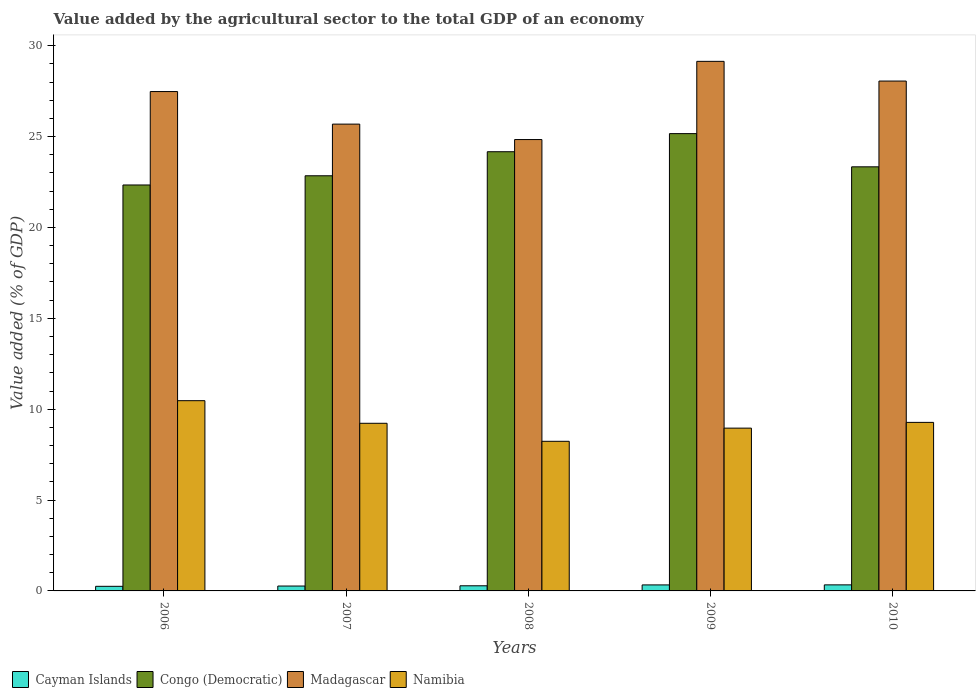How many different coloured bars are there?
Give a very brief answer. 4. Are the number of bars on each tick of the X-axis equal?
Offer a very short reply. Yes. In how many cases, is the number of bars for a given year not equal to the number of legend labels?
Offer a terse response. 0. What is the value added by the agricultural sector to the total GDP in Congo (Democratic) in 2009?
Provide a succinct answer. 25.16. Across all years, what is the maximum value added by the agricultural sector to the total GDP in Madagascar?
Make the answer very short. 29.14. Across all years, what is the minimum value added by the agricultural sector to the total GDP in Namibia?
Provide a succinct answer. 8.23. What is the total value added by the agricultural sector to the total GDP in Namibia in the graph?
Give a very brief answer. 46.16. What is the difference between the value added by the agricultural sector to the total GDP in Cayman Islands in 2007 and that in 2010?
Ensure brevity in your answer.  -0.06. What is the difference between the value added by the agricultural sector to the total GDP in Madagascar in 2007 and the value added by the agricultural sector to the total GDP in Cayman Islands in 2006?
Ensure brevity in your answer.  25.44. What is the average value added by the agricultural sector to the total GDP in Madagascar per year?
Give a very brief answer. 27.04. In the year 2010, what is the difference between the value added by the agricultural sector to the total GDP in Namibia and value added by the agricultural sector to the total GDP in Madagascar?
Offer a very short reply. -18.78. What is the ratio of the value added by the agricultural sector to the total GDP in Namibia in 2009 to that in 2010?
Keep it short and to the point. 0.97. Is the difference between the value added by the agricultural sector to the total GDP in Namibia in 2006 and 2010 greater than the difference between the value added by the agricultural sector to the total GDP in Madagascar in 2006 and 2010?
Your response must be concise. Yes. What is the difference between the highest and the second highest value added by the agricultural sector to the total GDP in Cayman Islands?
Ensure brevity in your answer.  0. What is the difference between the highest and the lowest value added by the agricultural sector to the total GDP in Congo (Democratic)?
Provide a short and direct response. 2.83. Is the sum of the value added by the agricultural sector to the total GDP in Cayman Islands in 2007 and 2010 greater than the maximum value added by the agricultural sector to the total GDP in Congo (Democratic) across all years?
Ensure brevity in your answer.  No. Is it the case that in every year, the sum of the value added by the agricultural sector to the total GDP in Congo (Democratic) and value added by the agricultural sector to the total GDP in Cayman Islands is greater than the sum of value added by the agricultural sector to the total GDP in Namibia and value added by the agricultural sector to the total GDP in Madagascar?
Provide a short and direct response. No. What does the 3rd bar from the left in 2009 represents?
Make the answer very short. Madagascar. What does the 4th bar from the right in 2008 represents?
Keep it short and to the point. Cayman Islands. Is it the case that in every year, the sum of the value added by the agricultural sector to the total GDP in Namibia and value added by the agricultural sector to the total GDP in Congo (Democratic) is greater than the value added by the agricultural sector to the total GDP in Madagascar?
Make the answer very short. Yes. How many bars are there?
Your answer should be very brief. 20. What is the difference between two consecutive major ticks on the Y-axis?
Your answer should be compact. 5. Does the graph contain any zero values?
Ensure brevity in your answer.  No. How are the legend labels stacked?
Keep it short and to the point. Horizontal. What is the title of the graph?
Offer a terse response. Value added by the agricultural sector to the total GDP of an economy. What is the label or title of the Y-axis?
Offer a very short reply. Value added (% of GDP). What is the Value added (% of GDP) of Cayman Islands in 2006?
Your answer should be compact. 0.25. What is the Value added (% of GDP) in Congo (Democratic) in 2006?
Offer a very short reply. 22.34. What is the Value added (% of GDP) of Madagascar in 2006?
Offer a very short reply. 27.48. What is the Value added (% of GDP) of Namibia in 2006?
Provide a succinct answer. 10.47. What is the Value added (% of GDP) in Cayman Islands in 2007?
Keep it short and to the point. 0.27. What is the Value added (% of GDP) in Congo (Democratic) in 2007?
Your response must be concise. 22.85. What is the Value added (% of GDP) in Madagascar in 2007?
Provide a succinct answer. 25.69. What is the Value added (% of GDP) of Namibia in 2007?
Make the answer very short. 9.22. What is the Value added (% of GDP) in Cayman Islands in 2008?
Keep it short and to the point. 0.28. What is the Value added (% of GDP) of Congo (Democratic) in 2008?
Offer a very short reply. 24.17. What is the Value added (% of GDP) of Madagascar in 2008?
Your response must be concise. 24.84. What is the Value added (% of GDP) in Namibia in 2008?
Offer a very short reply. 8.23. What is the Value added (% of GDP) in Cayman Islands in 2009?
Ensure brevity in your answer.  0.33. What is the Value added (% of GDP) in Congo (Democratic) in 2009?
Offer a terse response. 25.16. What is the Value added (% of GDP) of Madagascar in 2009?
Provide a short and direct response. 29.14. What is the Value added (% of GDP) of Namibia in 2009?
Your response must be concise. 8.96. What is the Value added (% of GDP) of Cayman Islands in 2010?
Your answer should be compact. 0.33. What is the Value added (% of GDP) in Congo (Democratic) in 2010?
Your answer should be compact. 23.34. What is the Value added (% of GDP) of Madagascar in 2010?
Provide a short and direct response. 28.06. What is the Value added (% of GDP) in Namibia in 2010?
Offer a very short reply. 9.27. Across all years, what is the maximum Value added (% of GDP) of Cayman Islands?
Provide a succinct answer. 0.33. Across all years, what is the maximum Value added (% of GDP) in Congo (Democratic)?
Offer a very short reply. 25.16. Across all years, what is the maximum Value added (% of GDP) in Madagascar?
Ensure brevity in your answer.  29.14. Across all years, what is the maximum Value added (% of GDP) of Namibia?
Your answer should be very brief. 10.47. Across all years, what is the minimum Value added (% of GDP) of Cayman Islands?
Your answer should be very brief. 0.25. Across all years, what is the minimum Value added (% of GDP) of Congo (Democratic)?
Your answer should be very brief. 22.34. Across all years, what is the minimum Value added (% of GDP) in Madagascar?
Your answer should be very brief. 24.84. Across all years, what is the minimum Value added (% of GDP) in Namibia?
Ensure brevity in your answer.  8.23. What is the total Value added (% of GDP) in Cayman Islands in the graph?
Offer a terse response. 1.47. What is the total Value added (% of GDP) of Congo (Democratic) in the graph?
Provide a short and direct response. 117.85. What is the total Value added (% of GDP) of Madagascar in the graph?
Your response must be concise. 135.21. What is the total Value added (% of GDP) in Namibia in the graph?
Make the answer very short. 46.16. What is the difference between the Value added (% of GDP) of Cayman Islands in 2006 and that in 2007?
Keep it short and to the point. -0.02. What is the difference between the Value added (% of GDP) in Congo (Democratic) in 2006 and that in 2007?
Your answer should be very brief. -0.51. What is the difference between the Value added (% of GDP) of Madagascar in 2006 and that in 2007?
Provide a short and direct response. 1.79. What is the difference between the Value added (% of GDP) of Namibia in 2006 and that in 2007?
Offer a very short reply. 1.24. What is the difference between the Value added (% of GDP) in Cayman Islands in 2006 and that in 2008?
Your answer should be compact. -0.03. What is the difference between the Value added (% of GDP) of Congo (Democratic) in 2006 and that in 2008?
Offer a very short reply. -1.83. What is the difference between the Value added (% of GDP) in Madagascar in 2006 and that in 2008?
Offer a very short reply. 2.64. What is the difference between the Value added (% of GDP) of Namibia in 2006 and that in 2008?
Your answer should be very brief. 2.24. What is the difference between the Value added (% of GDP) in Cayman Islands in 2006 and that in 2009?
Provide a short and direct response. -0.08. What is the difference between the Value added (% of GDP) in Congo (Democratic) in 2006 and that in 2009?
Ensure brevity in your answer.  -2.83. What is the difference between the Value added (% of GDP) of Madagascar in 2006 and that in 2009?
Ensure brevity in your answer.  -1.66. What is the difference between the Value added (% of GDP) of Namibia in 2006 and that in 2009?
Ensure brevity in your answer.  1.51. What is the difference between the Value added (% of GDP) in Cayman Islands in 2006 and that in 2010?
Ensure brevity in your answer.  -0.08. What is the difference between the Value added (% of GDP) of Congo (Democratic) in 2006 and that in 2010?
Offer a terse response. -1. What is the difference between the Value added (% of GDP) of Madagascar in 2006 and that in 2010?
Provide a short and direct response. -0.58. What is the difference between the Value added (% of GDP) in Namibia in 2006 and that in 2010?
Your answer should be very brief. 1.19. What is the difference between the Value added (% of GDP) of Cayman Islands in 2007 and that in 2008?
Your response must be concise. -0.01. What is the difference between the Value added (% of GDP) in Congo (Democratic) in 2007 and that in 2008?
Your answer should be compact. -1.32. What is the difference between the Value added (% of GDP) of Madagascar in 2007 and that in 2008?
Make the answer very short. 0.85. What is the difference between the Value added (% of GDP) in Cayman Islands in 2007 and that in 2009?
Make the answer very short. -0.06. What is the difference between the Value added (% of GDP) of Congo (Democratic) in 2007 and that in 2009?
Your response must be concise. -2.32. What is the difference between the Value added (% of GDP) of Madagascar in 2007 and that in 2009?
Your answer should be compact. -3.45. What is the difference between the Value added (% of GDP) of Namibia in 2007 and that in 2009?
Keep it short and to the point. 0.27. What is the difference between the Value added (% of GDP) in Cayman Islands in 2007 and that in 2010?
Offer a terse response. -0.06. What is the difference between the Value added (% of GDP) of Congo (Democratic) in 2007 and that in 2010?
Offer a very short reply. -0.49. What is the difference between the Value added (% of GDP) of Madagascar in 2007 and that in 2010?
Offer a very short reply. -2.37. What is the difference between the Value added (% of GDP) in Namibia in 2007 and that in 2010?
Provide a succinct answer. -0.05. What is the difference between the Value added (% of GDP) in Cayman Islands in 2008 and that in 2009?
Offer a terse response. -0.05. What is the difference between the Value added (% of GDP) in Congo (Democratic) in 2008 and that in 2009?
Offer a terse response. -1. What is the difference between the Value added (% of GDP) in Madagascar in 2008 and that in 2009?
Give a very brief answer. -4.3. What is the difference between the Value added (% of GDP) in Namibia in 2008 and that in 2009?
Offer a very short reply. -0.72. What is the difference between the Value added (% of GDP) of Cayman Islands in 2008 and that in 2010?
Provide a succinct answer. -0.05. What is the difference between the Value added (% of GDP) of Congo (Democratic) in 2008 and that in 2010?
Ensure brevity in your answer.  0.83. What is the difference between the Value added (% of GDP) of Madagascar in 2008 and that in 2010?
Offer a terse response. -3.22. What is the difference between the Value added (% of GDP) in Namibia in 2008 and that in 2010?
Your answer should be compact. -1.04. What is the difference between the Value added (% of GDP) of Cayman Islands in 2009 and that in 2010?
Make the answer very short. -0. What is the difference between the Value added (% of GDP) in Congo (Democratic) in 2009 and that in 2010?
Your answer should be compact. 1.83. What is the difference between the Value added (% of GDP) of Madagascar in 2009 and that in 2010?
Offer a terse response. 1.08. What is the difference between the Value added (% of GDP) of Namibia in 2009 and that in 2010?
Ensure brevity in your answer.  -0.32. What is the difference between the Value added (% of GDP) of Cayman Islands in 2006 and the Value added (% of GDP) of Congo (Democratic) in 2007?
Your response must be concise. -22.59. What is the difference between the Value added (% of GDP) in Cayman Islands in 2006 and the Value added (% of GDP) in Madagascar in 2007?
Your answer should be very brief. -25.44. What is the difference between the Value added (% of GDP) in Cayman Islands in 2006 and the Value added (% of GDP) in Namibia in 2007?
Make the answer very short. -8.97. What is the difference between the Value added (% of GDP) of Congo (Democratic) in 2006 and the Value added (% of GDP) of Madagascar in 2007?
Give a very brief answer. -3.35. What is the difference between the Value added (% of GDP) of Congo (Democratic) in 2006 and the Value added (% of GDP) of Namibia in 2007?
Ensure brevity in your answer.  13.11. What is the difference between the Value added (% of GDP) of Madagascar in 2006 and the Value added (% of GDP) of Namibia in 2007?
Provide a short and direct response. 18.26. What is the difference between the Value added (% of GDP) in Cayman Islands in 2006 and the Value added (% of GDP) in Congo (Democratic) in 2008?
Provide a succinct answer. -23.92. What is the difference between the Value added (% of GDP) of Cayman Islands in 2006 and the Value added (% of GDP) of Madagascar in 2008?
Ensure brevity in your answer.  -24.59. What is the difference between the Value added (% of GDP) of Cayman Islands in 2006 and the Value added (% of GDP) of Namibia in 2008?
Your response must be concise. -7.98. What is the difference between the Value added (% of GDP) in Congo (Democratic) in 2006 and the Value added (% of GDP) in Madagascar in 2008?
Keep it short and to the point. -2.5. What is the difference between the Value added (% of GDP) in Congo (Democratic) in 2006 and the Value added (% of GDP) in Namibia in 2008?
Give a very brief answer. 14.11. What is the difference between the Value added (% of GDP) of Madagascar in 2006 and the Value added (% of GDP) of Namibia in 2008?
Your answer should be compact. 19.25. What is the difference between the Value added (% of GDP) in Cayman Islands in 2006 and the Value added (% of GDP) in Congo (Democratic) in 2009?
Your response must be concise. -24.91. What is the difference between the Value added (% of GDP) of Cayman Islands in 2006 and the Value added (% of GDP) of Madagascar in 2009?
Make the answer very short. -28.89. What is the difference between the Value added (% of GDP) of Cayman Islands in 2006 and the Value added (% of GDP) of Namibia in 2009?
Provide a succinct answer. -8.71. What is the difference between the Value added (% of GDP) of Congo (Democratic) in 2006 and the Value added (% of GDP) of Madagascar in 2009?
Keep it short and to the point. -6.8. What is the difference between the Value added (% of GDP) in Congo (Democratic) in 2006 and the Value added (% of GDP) in Namibia in 2009?
Give a very brief answer. 13.38. What is the difference between the Value added (% of GDP) of Madagascar in 2006 and the Value added (% of GDP) of Namibia in 2009?
Provide a succinct answer. 18.52. What is the difference between the Value added (% of GDP) in Cayman Islands in 2006 and the Value added (% of GDP) in Congo (Democratic) in 2010?
Offer a very short reply. -23.08. What is the difference between the Value added (% of GDP) of Cayman Islands in 2006 and the Value added (% of GDP) of Madagascar in 2010?
Offer a terse response. -27.8. What is the difference between the Value added (% of GDP) of Cayman Islands in 2006 and the Value added (% of GDP) of Namibia in 2010?
Ensure brevity in your answer.  -9.02. What is the difference between the Value added (% of GDP) in Congo (Democratic) in 2006 and the Value added (% of GDP) in Madagascar in 2010?
Offer a very short reply. -5.72. What is the difference between the Value added (% of GDP) in Congo (Democratic) in 2006 and the Value added (% of GDP) in Namibia in 2010?
Ensure brevity in your answer.  13.06. What is the difference between the Value added (% of GDP) in Madagascar in 2006 and the Value added (% of GDP) in Namibia in 2010?
Give a very brief answer. 18.21. What is the difference between the Value added (% of GDP) of Cayman Islands in 2007 and the Value added (% of GDP) of Congo (Democratic) in 2008?
Your answer should be very brief. -23.9. What is the difference between the Value added (% of GDP) in Cayman Islands in 2007 and the Value added (% of GDP) in Madagascar in 2008?
Offer a very short reply. -24.57. What is the difference between the Value added (% of GDP) in Cayman Islands in 2007 and the Value added (% of GDP) in Namibia in 2008?
Your answer should be very brief. -7.96. What is the difference between the Value added (% of GDP) of Congo (Democratic) in 2007 and the Value added (% of GDP) of Madagascar in 2008?
Your response must be concise. -1.99. What is the difference between the Value added (% of GDP) in Congo (Democratic) in 2007 and the Value added (% of GDP) in Namibia in 2008?
Make the answer very short. 14.61. What is the difference between the Value added (% of GDP) of Madagascar in 2007 and the Value added (% of GDP) of Namibia in 2008?
Provide a short and direct response. 17.45. What is the difference between the Value added (% of GDP) of Cayman Islands in 2007 and the Value added (% of GDP) of Congo (Democratic) in 2009?
Provide a short and direct response. -24.9. What is the difference between the Value added (% of GDP) of Cayman Islands in 2007 and the Value added (% of GDP) of Madagascar in 2009?
Offer a very short reply. -28.87. What is the difference between the Value added (% of GDP) of Cayman Islands in 2007 and the Value added (% of GDP) of Namibia in 2009?
Ensure brevity in your answer.  -8.69. What is the difference between the Value added (% of GDP) in Congo (Democratic) in 2007 and the Value added (% of GDP) in Madagascar in 2009?
Offer a very short reply. -6.3. What is the difference between the Value added (% of GDP) in Congo (Democratic) in 2007 and the Value added (% of GDP) in Namibia in 2009?
Provide a succinct answer. 13.89. What is the difference between the Value added (% of GDP) in Madagascar in 2007 and the Value added (% of GDP) in Namibia in 2009?
Keep it short and to the point. 16.73. What is the difference between the Value added (% of GDP) of Cayman Islands in 2007 and the Value added (% of GDP) of Congo (Democratic) in 2010?
Your response must be concise. -23.07. What is the difference between the Value added (% of GDP) of Cayman Islands in 2007 and the Value added (% of GDP) of Madagascar in 2010?
Provide a succinct answer. -27.79. What is the difference between the Value added (% of GDP) of Cayman Islands in 2007 and the Value added (% of GDP) of Namibia in 2010?
Give a very brief answer. -9.01. What is the difference between the Value added (% of GDP) of Congo (Democratic) in 2007 and the Value added (% of GDP) of Madagascar in 2010?
Ensure brevity in your answer.  -5.21. What is the difference between the Value added (% of GDP) in Congo (Democratic) in 2007 and the Value added (% of GDP) in Namibia in 2010?
Provide a succinct answer. 13.57. What is the difference between the Value added (% of GDP) in Madagascar in 2007 and the Value added (% of GDP) in Namibia in 2010?
Provide a succinct answer. 16.41. What is the difference between the Value added (% of GDP) in Cayman Islands in 2008 and the Value added (% of GDP) in Congo (Democratic) in 2009?
Give a very brief answer. -24.88. What is the difference between the Value added (% of GDP) in Cayman Islands in 2008 and the Value added (% of GDP) in Madagascar in 2009?
Provide a succinct answer. -28.86. What is the difference between the Value added (% of GDP) in Cayman Islands in 2008 and the Value added (% of GDP) in Namibia in 2009?
Provide a short and direct response. -8.68. What is the difference between the Value added (% of GDP) of Congo (Democratic) in 2008 and the Value added (% of GDP) of Madagascar in 2009?
Give a very brief answer. -4.97. What is the difference between the Value added (% of GDP) of Congo (Democratic) in 2008 and the Value added (% of GDP) of Namibia in 2009?
Ensure brevity in your answer.  15.21. What is the difference between the Value added (% of GDP) in Madagascar in 2008 and the Value added (% of GDP) in Namibia in 2009?
Offer a very short reply. 15.88. What is the difference between the Value added (% of GDP) in Cayman Islands in 2008 and the Value added (% of GDP) in Congo (Democratic) in 2010?
Your answer should be compact. -23.06. What is the difference between the Value added (% of GDP) in Cayman Islands in 2008 and the Value added (% of GDP) in Madagascar in 2010?
Give a very brief answer. -27.78. What is the difference between the Value added (% of GDP) in Cayman Islands in 2008 and the Value added (% of GDP) in Namibia in 2010?
Provide a short and direct response. -8.99. What is the difference between the Value added (% of GDP) of Congo (Democratic) in 2008 and the Value added (% of GDP) of Madagascar in 2010?
Offer a terse response. -3.89. What is the difference between the Value added (% of GDP) in Congo (Democratic) in 2008 and the Value added (% of GDP) in Namibia in 2010?
Keep it short and to the point. 14.89. What is the difference between the Value added (% of GDP) in Madagascar in 2008 and the Value added (% of GDP) in Namibia in 2010?
Ensure brevity in your answer.  15.56. What is the difference between the Value added (% of GDP) in Cayman Islands in 2009 and the Value added (% of GDP) in Congo (Democratic) in 2010?
Offer a very short reply. -23.01. What is the difference between the Value added (% of GDP) in Cayman Islands in 2009 and the Value added (% of GDP) in Madagascar in 2010?
Offer a terse response. -27.73. What is the difference between the Value added (% of GDP) in Cayman Islands in 2009 and the Value added (% of GDP) in Namibia in 2010?
Ensure brevity in your answer.  -8.94. What is the difference between the Value added (% of GDP) of Congo (Democratic) in 2009 and the Value added (% of GDP) of Madagascar in 2010?
Offer a terse response. -2.89. What is the difference between the Value added (% of GDP) of Congo (Democratic) in 2009 and the Value added (% of GDP) of Namibia in 2010?
Ensure brevity in your answer.  15.89. What is the difference between the Value added (% of GDP) of Madagascar in 2009 and the Value added (% of GDP) of Namibia in 2010?
Your answer should be very brief. 19.87. What is the average Value added (% of GDP) in Cayman Islands per year?
Offer a very short reply. 0.29. What is the average Value added (% of GDP) of Congo (Democratic) per year?
Provide a succinct answer. 23.57. What is the average Value added (% of GDP) in Madagascar per year?
Offer a terse response. 27.04. What is the average Value added (% of GDP) of Namibia per year?
Keep it short and to the point. 9.23. In the year 2006, what is the difference between the Value added (% of GDP) in Cayman Islands and Value added (% of GDP) in Congo (Democratic)?
Ensure brevity in your answer.  -22.09. In the year 2006, what is the difference between the Value added (% of GDP) in Cayman Islands and Value added (% of GDP) in Madagascar?
Give a very brief answer. -27.23. In the year 2006, what is the difference between the Value added (% of GDP) of Cayman Islands and Value added (% of GDP) of Namibia?
Provide a short and direct response. -10.22. In the year 2006, what is the difference between the Value added (% of GDP) of Congo (Democratic) and Value added (% of GDP) of Madagascar?
Offer a very short reply. -5.14. In the year 2006, what is the difference between the Value added (% of GDP) in Congo (Democratic) and Value added (% of GDP) in Namibia?
Give a very brief answer. 11.87. In the year 2006, what is the difference between the Value added (% of GDP) in Madagascar and Value added (% of GDP) in Namibia?
Offer a very short reply. 17.01. In the year 2007, what is the difference between the Value added (% of GDP) in Cayman Islands and Value added (% of GDP) in Congo (Democratic)?
Your response must be concise. -22.58. In the year 2007, what is the difference between the Value added (% of GDP) in Cayman Islands and Value added (% of GDP) in Madagascar?
Ensure brevity in your answer.  -25.42. In the year 2007, what is the difference between the Value added (% of GDP) in Cayman Islands and Value added (% of GDP) in Namibia?
Keep it short and to the point. -8.96. In the year 2007, what is the difference between the Value added (% of GDP) in Congo (Democratic) and Value added (% of GDP) in Madagascar?
Make the answer very short. -2.84. In the year 2007, what is the difference between the Value added (% of GDP) of Congo (Democratic) and Value added (% of GDP) of Namibia?
Keep it short and to the point. 13.62. In the year 2007, what is the difference between the Value added (% of GDP) of Madagascar and Value added (% of GDP) of Namibia?
Your answer should be compact. 16.46. In the year 2008, what is the difference between the Value added (% of GDP) in Cayman Islands and Value added (% of GDP) in Congo (Democratic)?
Your response must be concise. -23.89. In the year 2008, what is the difference between the Value added (% of GDP) in Cayman Islands and Value added (% of GDP) in Madagascar?
Your response must be concise. -24.56. In the year 2008, what is the difference between the Value added (% of GDP) of Cayman Islands and Value added (% of GDP) of Namibia?
Provide a succinct answer. -7.95. In the year 2008, what is the difference between the Value added (% of GDP) in Congo (Democratic) and Value added (% of GDP) in Madagascar?
Your answer should be compact. -0.67. In the year 2008, what is the difference between the Value added (% of GDP) of Congo (Democratic) and Value added (% of GDP) of Namibia?
Ensure brevity in your answer.  15.94. In the year 2008, what is the difference between the Value added (% of GDP) of Madagascar and Value added (% of GDP) of Namibia?
Offer a terse response. 16.61. In the year 2009, what is the difference between the Value added (% of GDP) in Cayman Islands and Value added (% of GDP) in Congo (Democratic)?
Offer a very short reply. -24.83. In the year 2009, what is the difference between the Value added (% of GDP) of Cayman Islands and Value added (% of GDP) of Madagascar?
Offer a terse response. -28.81. In the year 2009, what is the difference between the Value added (% of GDP) in Cayman Islands and Value added (% of GDP) in Namibia?
Ensure brevity in your answer.  -8.63. In the year 2009, what is the difference between the Value added (% of GDP) of Congo (Democratic) and Value added (% of GDP) of Madagascar?
Offer a terse response. -3.98. In the year 2009, what is the difference between the Value added (% of GDP) in Congo (Democratic) and Value added (% of GDP) in Namibia?
Ensure brevity in your answer.  16.21. In the year 2009, what is the difference between the Value added (% of GDP) in Madagascar and Value added (% of GDP) in Namibia?
Keep it short and to the point. 20.18. In the year 2010, what is the difference between the Value added (% of GDP) in Cayman Islands and Value added (% of GDP) in Congo (Democratic)?
Your answer should be compact. -23. In the year 2010, what is the difference between the Value added (% of GDP) in Cayman Islands and Value added (% of GDP) in Madagascar?
Offer a terse response. -27.72. In the year 2010, what is the difference between the Value added (% of GDP) of Cayman Islands and Value added (% of GDP) of Namibia?
Offer a very short reply. -8.94. In the year 2010, what is the difference between the Value added (% of GDP) in Congo (Democratic) and Value added (% of GDP) in Madagascar?
Make the answer very short. -4.72. In the year 2010, what is the difference between the Value added (% of GDP) of Congo (Democratic) and Value added (% of GDP) of Namibia?
Keep it short and to the point. 14.06. In the year 2010, what is the difference between the Value added (% of GDP) in Madagascar and Value added (% of GDP) in Namibia?
Ensure brevity in your answer.  18.78. What is the ratio of the Value added (% of GDP) of Cayman Islands in 2006 to that in 2007?
Make the answer very short. 0.94. What is the ratio of the Value added (% of GDP) of Congo (Democratic) in 2006 to that in 2007?
Ensure brevity in your answer.  0.98. What is the ratio of the Value added (% of GDP) in Madagascar in 2006 to that in 2007?
Your response must be concise. 1.07. What is the ratio of the Value added (% of GDP) of Namibia in 2006 to that in 2007?
Your answer should be compact. 1.13. What is the ratio of the Value added (% of GDP) of Cayman Islands in 2006 to that in 2008?
Ensure brevity in your answer.  0.9. What is the ratio of the Value added (% of GDP) in Congo (Democratic) in 2006 to that in 2008?
Offer a very short reply. 0.92. What is the ratio of the Value added (% of GDP) of Madagascar in 2006 to that in 2008?
Provide a short and direct response. 1.11. What is the ratio of the Value added (% of GDP) of Namibia in 2006 to that in 2008?
Your answer should be compact. 1.27. What is the ratio of the Value added (% of GDP) of Cayman Islands in 2006 to that in 2009?
Keep it short and to the point. 0.76. What is the ratio of the Value added (% of GDP) in Congo (Democratic) in 2006 to that in 2009?
Ensure brevity in your answer.  0.89. What is the ratio of the Value added (% of GDP) of Madagascar in 2006 to that in 2009?
Your response must be concise. 0.94. What is the ratio of the Value added (% of GDP) of Namibia in 2006 to that in 2009?
Keep it short and to the point. 1.17. What is the ratio of the Value added (% of GDP) of Cayman Islands in 2006 to that in 2010?
Your answer should be compact. 0.76. What is the ratio of the Value added (% of GDP) in Congo (Democratic) in 2006 to that in 2010?
Keep it short and to the point. 0.96. What is the ratio of the Value added (% of GDP) of Madagascar in 2006 to that in 2010?
Your answer should be very brief. 0.98. What is the ratio of the Value added (% of GDP) in Namibia in 2006 to that in 2010?
Offer a very short reply. 1.13. What is the ratio of the Value added (% of GDP) in Cayman Islands in 2007 to that in 2008?
Your response must be concise. 0.95. What is the ratio of the Value added (% of GDP) in Congo (Democratic) in 2007 to that in 2008?
Provide a succinct answer. 0.95. What is the ratio of the Value added (% of GDP) in Madagascar in 2007 to that in 2008?
Ensure brevity in your answer.  1.03. What is the ratio of the Value added (% of GDP) in Namibia in 2007 to that in 2008?
Ensure brevity in your answer.  1.12. What is the ratio of the Value added (% of GDP) of Cayman Islands in 2007 to that in 2009?
Offer a terse response. 0.81. What is the ratio of the Value added (% of GDP) of Congo (Democratic) in 2007 to that in 2009?
Your response must be concise. 0.91. What is the ratio of the Value added (% of GDP) in Madagascar in 2007 to that in 2009?
Give a very brief answer. 0.88. What is the ratio of the Value added (% of GDP) of Namibia in 2007 to that in 2009?
Your answer should be very brief. 1.03. What is the ratio of the Value added (% of GDP) of Cayman Islands in 2007 to that in 2010?
Your answer should be compact. 0.81. What is the ratio of the Value added (% of GDP) in Congo (Democratic) in 2007 to that in 2010?
Offer a terse response. 0.98. What is the ratio of the Value added (% of GDP) in Madagascar in 2007 to that in 2010?
Provide a short and direct response. 0.92. What is the ratio of the Value added (% of GDP) in Cayman Islands in 2008 to that in 2009?
Give a very brief answer. 0.85. What is the ratio of the Value added (% of GDP) in Congo (Democratic) in 2008 to that in 2009?
Your answer should be very brief. 0.96. What is the ratio of the Value added (% of GDP) in Madagascar in 2008 to that in 2009?
Make the answer very short. 0.85. What is the ratio of the Value added (% of GDP) in Namibia in 2008 to that in 2009?
Ensure brevity in your answer.  0.92. What is the ratio of the Value added (% of GDP) in Cayman Islands in 2008 to that in 2010?
Your response must be concise. 0.85. What is the ratio of the Value added (% of GDP) in Congo (Democratic) in 2008 to that in 2010?
Make the answer very short. 1.04. What is the ratio of the Value added (% of GDP) in Madagascar in 2008 to that in 2010?
Offer a very short reply. 0.89. What is the ratio of the Value added (% of GDP) in Namibia in 2008 to that in 2010?
Your answer should be compact. 0.89. What is the ratio of the Value added (% of GDP) in Cayman Islands in 2009 to that in 2010?
Provide a short and direct response. 0.99. What is the ratio of the Value added (% of GDP) of Congo (Democratic) in 2009 to that in 2010?
Offer a terse response. 1.08. What is the ratio of the Value added (% of GDP) of Madagascar in 2009 to that in 2010?
Keep it short and to the point. 1.04. What is the ratio of the Value added (% of GDP) in Namibia in 2009 to that in 2010?
Offer a very short reply. 0.97. What is the difference between the highest and the second highest Value added (% of GDP) in Cayman Islands?
Your response must be concise. 0. What is the difference between the highest and the second highest Value added (% of GDP) in Congo (Democratic)?
Keep it short and to the point. 1. What is the difference between the highest and the second highest Value added (% of GDP) of Madagascar?
Your answer should be very brief. 1.08. What is the difference between the highest and the second highest Value added (% of GDP) in Namibia?
Your answer should be compact. 1.19. What is the difference between the highest and the lowest Value added (% of GDP) of Cayman Islands?
Your response must be concise. 0.08. What is the difference between the highest and the lowest Value added (% of GDP) of Congo (Democratic)?
Your answer should be compact. 2.83. What is the difference between the highest and the lowest Value added (% of GDP) of Madagascar?
Provide a succinct answer. 4.3. What is the difference between the highest and the lowest Value added (% of GDP) of Namibia?
Ensure brevity in your answer.  2.24. 